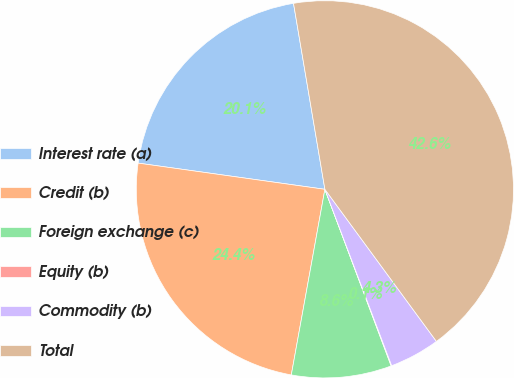Convert chart to OTSL. <chart><loc_0><loc_0><loc_500><loc_500><pie_chart><fcel>Interest rate (a)<fcel>Credit (b)<fcel>Foreign exchange (c)<fcel>Equity (b)<fcel>Commodity (b)<fcel>Total<nl><fcel>20.12%<fcel>24.37%<fcel>8.56%<fcel>0.05%<fcel>4.31%<fcel>42.59%<nl></chart> 